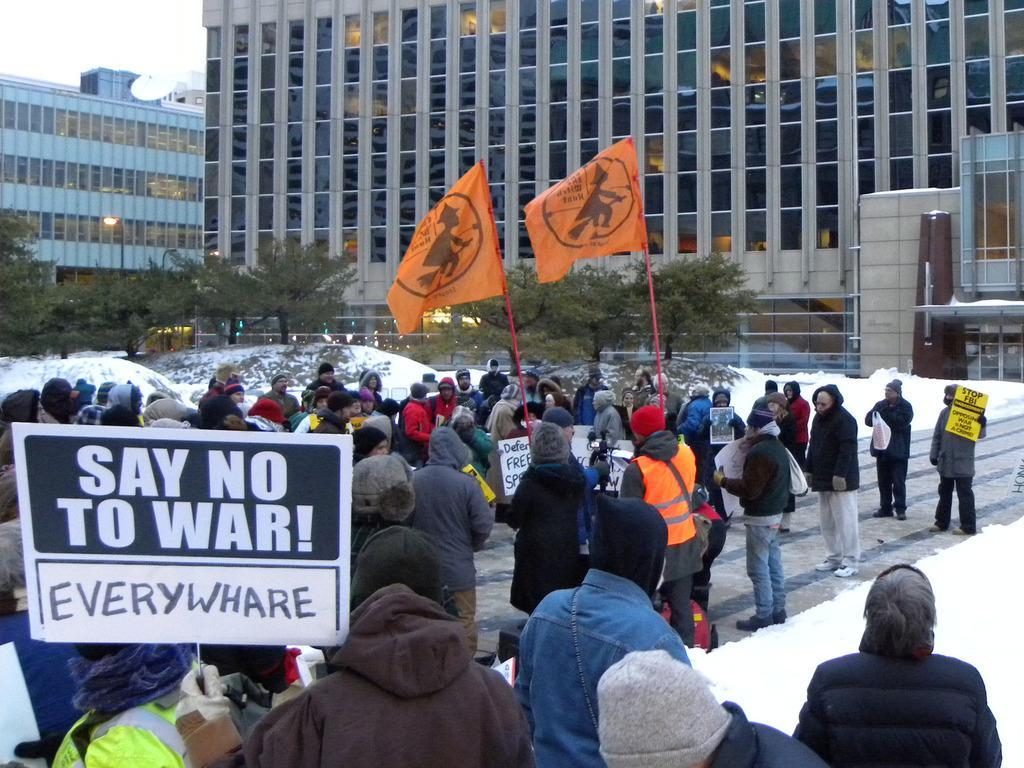In one or two sentences, can you explain what this image depicts? On the bottom there is a man who is wearing blue jacket and cap. He is standing near to the man who is the wearing hoodie and cap. He is also holding a sign board. Here we can see two persons are holding this orange color flag. Here we can see group of person standing on the road. On the right we can see person who is holding yellow color poster and standing near to the snow. In the back we can see trees, building and vehicles. On the top left corner there is a sky. 